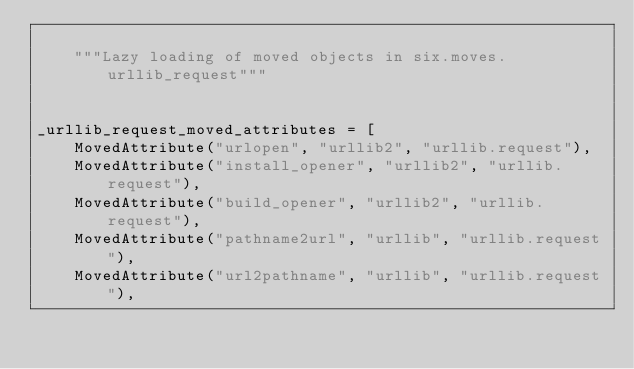Convert code to text. <code><loc_0><loc_0><loc_500><loc_500><_Python_>
    """Lazy loading of moved objects in six.moves.urllib_request"""


_urllib_request_moved_attributes = [
    MovedAttribute("urlopen", "urllib2", "urllib.request"),
    MovedAttribute("install_opener", "urllib2", "urllib.request"),
    MovedAttribute("build_opener", "urllib2", "urllib.request"),
    MovedAttribute("pathname2url", "urllib", "urllib.request"),
    MovedAttribute("url2pathname", "urllib", "urllib.request"),</code> 